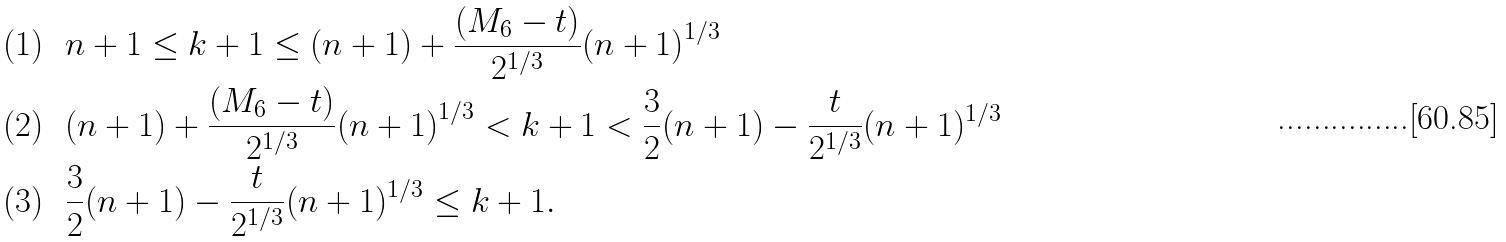<formula> <loc_0><loc_0><loc_500><loc_500>( 1 ) \ \ & n + 1 \leq k + 1 \leq ( n + 1 ) + \frac { ( M _ { 6 } - t ) } { 2 ^ { 1 / 3 } } { ( n + 1 ) } ^ { 1 / 3 } \\ ( 2 ) \ \ & ( n + 1 ) + \frac { ( M _ { 6 } - t ) } { 2 ^ { 1 / 3 } } { ( n + 1 ) } ^ { 1 / 3 } < k + 1 < \frac { 3 } { 2 } ( n + 1 ) - \frac { t } { 2 ^ { 1 / 3 } } ( n + 1 ) ^ { 1 / 3 } \\ ( 3 ) \ \ & \frac { 3 } { 2 } ( n + 1 ) - \frac { t } { 2 ^ { 1 / 3 } } ( n + 1 ) ^ { 1 / 3 } \leq k + 1 .</formula> 